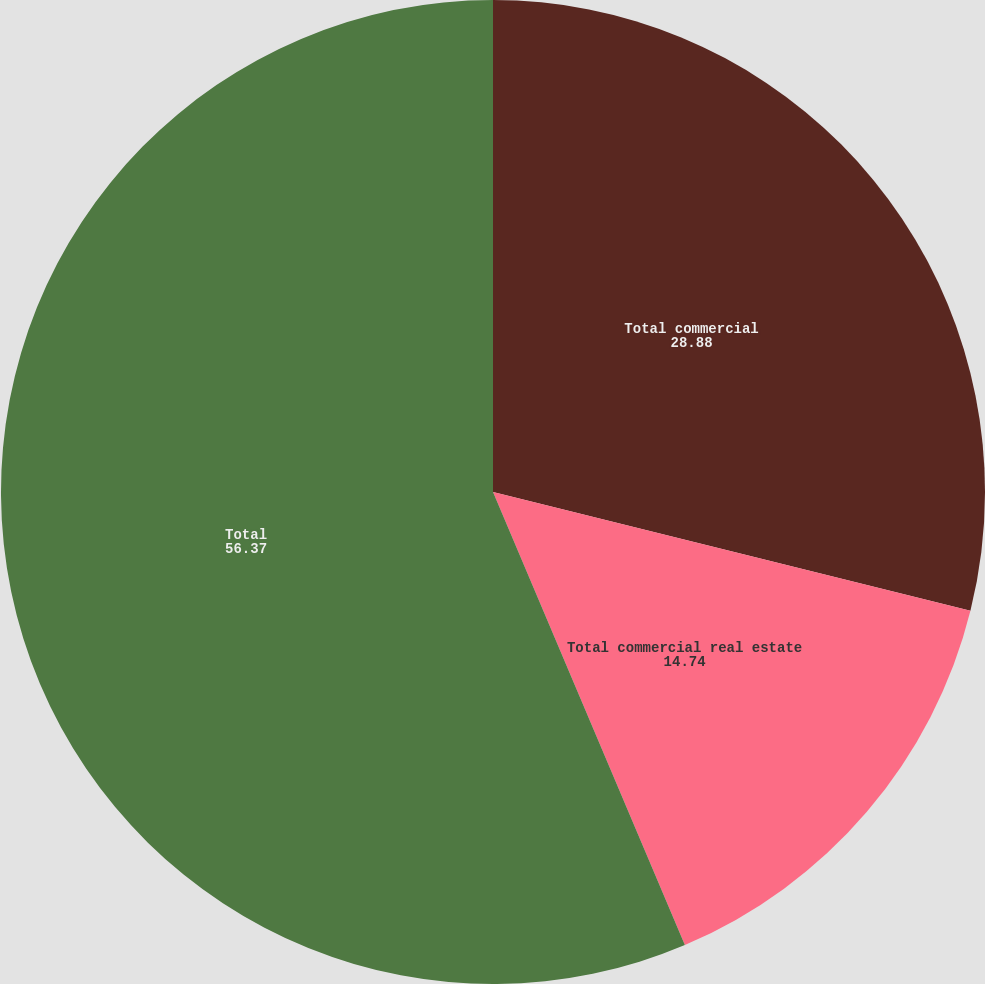Convert chart. <chart><loc_0><loc_0><loc_500><loc_500><pie_chart><fcel>Total commercial<fcel>Total commercial real estate<fcel>Total<nl><fcel>28.88%<fcel>14.74%<fcel>56.37%<nl></chart> 